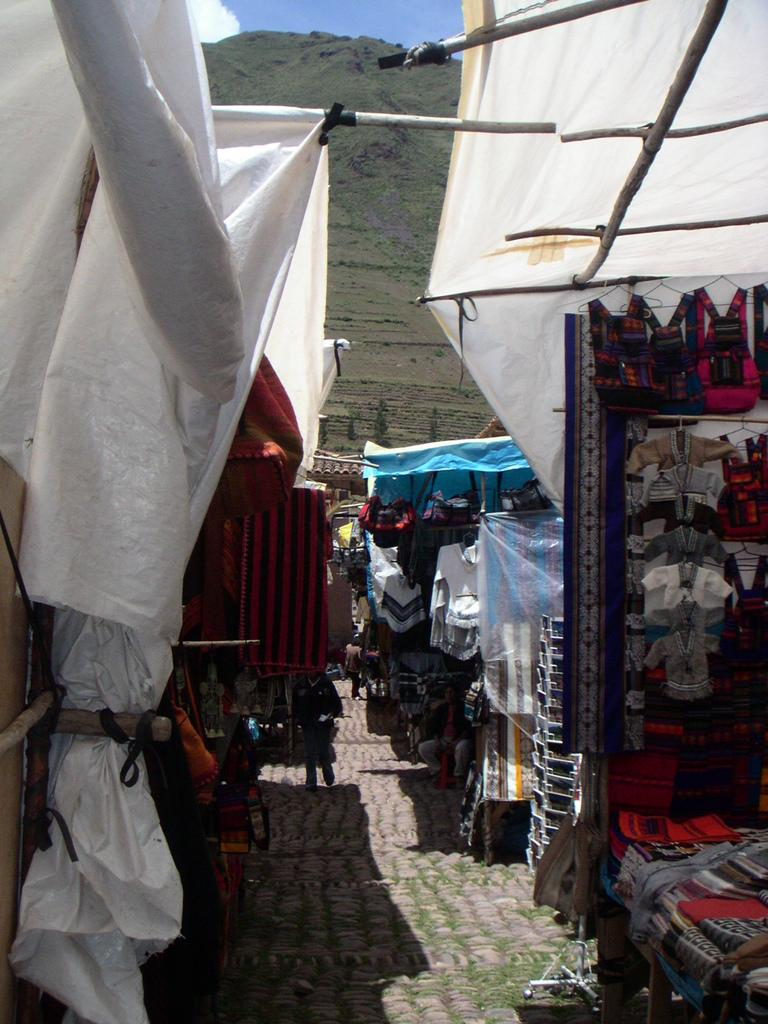What type of structures are present in the image? There are stalls in the image. What can be seen in the distance behind the stalls? There is a mountain in the background of the image. What else is visible in the background of the image? The sky is visible in the background of the image. How many sisters are standing next to the stalls in the image? There is no mention of sisters in the image, so we cannot determine their presence or number. 